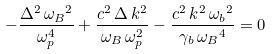<formula> <loc_0><loc_0><loc_500><loc_500>- { \frac { { { \Delta } ^ { 2 } } \, { { \omega _ { B } } ^ { 2 } } } { \omega _ { p } ^ { 4 } } } + { \frac { { c ^ { 2 } } \, \Delta \, k ^ { 2 } } { { \omega _ { B } } \, \omega _ { p } ^ { 2 } } } - { \frac { { c ^ { 2 } } \, k ^ { 2 } \, { \omega _ { b } } ^ { 2 } } { \gamma _ { b } \, { { \omega _ { B } } ^ { 4 } } } } = 0</formula> 